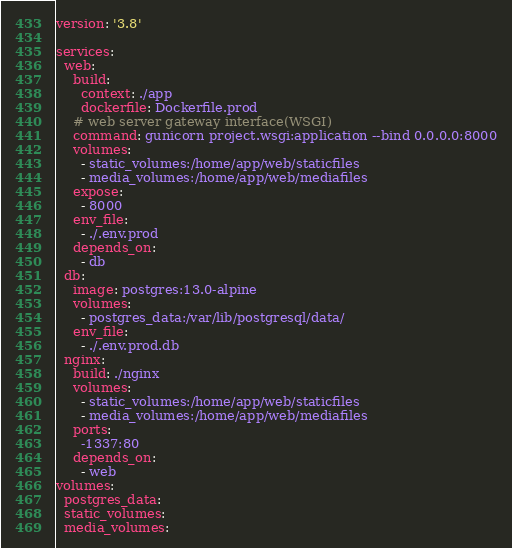<code> <loc_0><loc_0><loc_500><loc_500><_YAML_>version: '3.8'

services:
  web:
    build: 
      context: ./app
      dockerfile: Dockerfile.prod
    # web server gateway interface(WSGI)
    command: gunicorn project.wsgi:application --bind 0.0.0.0:8000
    volumes:
      - static_volumes:/home/app/web/staticfiles
      - media_volumes:/home/app/web/mediafiles
    expose:
      - 8000
    env_file:
      - ./.env.prod
    depends_on:
      - db
  db:
    image: postgres:13.0-alpine
    volumes: 
      - postgres_data:/var/lib/postgresql/data/
    env_file:
      - ./.env.prod.db
  nginx:
    build: ./nginx
    volumes:
      - static_volumes:/home/app/web/staticfiles
      - media_volumes:/home/app/web/mediafiles
    ports:
      -1337:80
    depends_on:
      - web
volumes:
  postgres_data:
  static_volumes:
  media_volumes:
</code> 